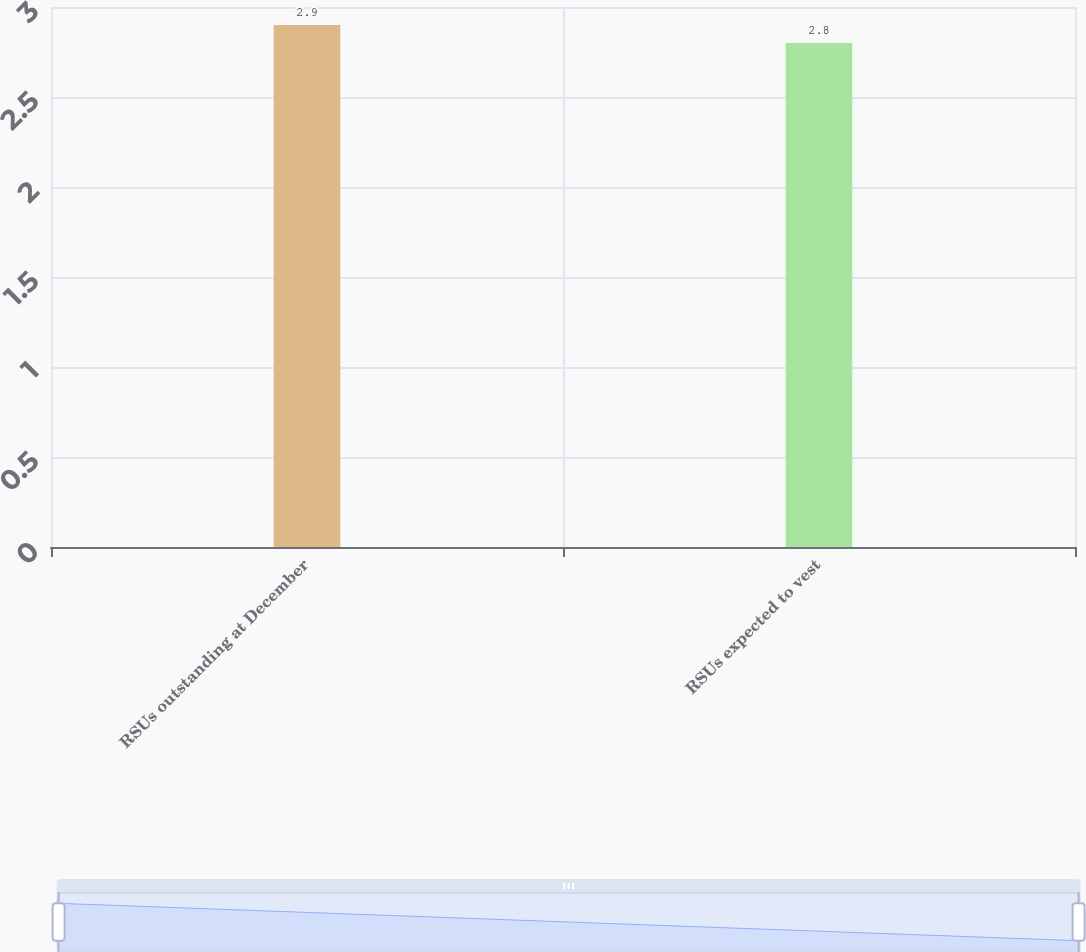Convert chart. <chart><loc_0><loc_0><loc_500><loc_500><bar_chart><fcel>RSUs outstanding at December<fcel>RSUs expected to vest<nl><fcel>2.9<fcel>2.8<nl></chart> 